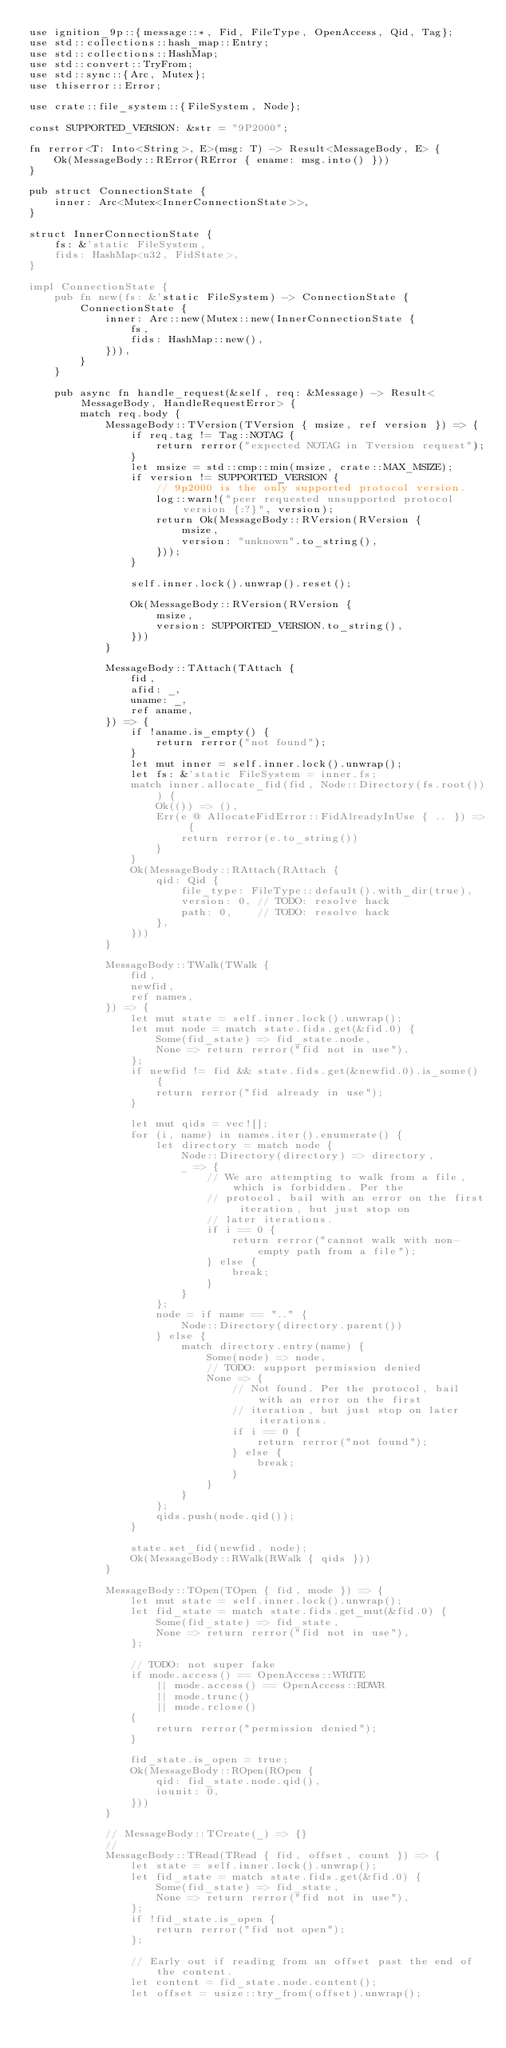Convert code to text. <code><loc_0><loc_0><loc_500><loc_500><_Rust_>use ignition_9p::{message::*, Fid, FileType, OpenAccess, Qid, Tag};
use std::collections::hash_map::Entry;
use std::collections::HashMap;
use std::convert::TryFrom;
use std::sync::{Arc, Mutex};
use thiserror::Error;

use crate::file_system::{FileSystem, Node};

const SUPPORTED_VERSION: &str = "9P2000";

fn rerror<T: Into<String>, E>(msg: T) -> Result<MessageBody, E> {
    Ok(MessageBody::RError(RError { ename: msg.into() }))
}

pub struct ConnectionState {
    inner: Arc<Mutex<InnerConnectionState>>,
}

struct InnerConnectionState {
    fs: &'static FileSystem,
    fids: HashMap<u32, FidState>,
}

impl ConnectionState {
    pub fn new(fs: &'static FileSystem) -> ConnectionState {
        ConnectionState {
            inner: Arc::new(Mutex::new(InnerConnectionState {
                fs,
                fids: HashMap::new(),
            })),
        }
    }

    pub async fn handle_request(&self, req: &Message) -> Result<MessageBody, HandleRequestError> {
        match req.body {
            MessageBody::TVersion(TVersion { msize, ref version }) => {
                if req.tag != Tag::NOTAG {
                    return rerror("expected NOTAG in Tversion request");
                }
                let msize = std::cmp::min(msize, crate::MAX_MSIZE);
                if version != SUPPORTED_VERSION {
                    // 9p2000 is the only supported protocol version.
                    log::warn!("peer requested unsupported protocol version {:?}", version);
                    return Ok(MessageBody::RVersion(RVersion {
                        msize,
                        version: "unknown".to_string(),
                    }));
                }

                self.inner.lock().unwrap().reset();

                Ok(MessageBody::RVersion(RVersion {
                    msize,
                    version: SUPPORTED_VERSION.to_string(),
                }))
            }

            MessageBody::TAttach(TAttach {
                fid,
                afid: _,
                uname: _,
                ref aname,
            }) => {
                if !aname.is_empty() {
                    return rerror("not found");
                }
                let mut inner = self.inner.lock().unwrap();
                let fs: &'static FileSystem = inner.fs;
                match inner.allocate_fid(fid, Node::Directory(fs.root())) {
                    Ok(()) => (),
                    Err(e @ AllocateFidError::FidAlreadyInUse { .. }) => {
                        return rerror(e.to_string())
                    }
                }
                Ok(MessageBody::RAttach(RAttach {
                    qid: Qid {
                        file_type: FileType::default().with_dir(true),
                        version: 0, // TODO: resolve hack
                        path: 0,    // TODO: resolve hack
                    },
                }))
            }

            MessageBody::TWalk(TWalk {
                fid,
                newfid,
                ref names,
            }) => {
                let mut state = self.inner.lock().unwrap();
                let mut node = match state.fids.get(&fid.0) {
                    Some(fid_state) => fid_state.node,
                    None => return rerror("fid not in use"),
                };
                if newfid != fid && state.fids.get(&newfid.0).is_some() {
                    return rerror("fid already in use");
                }

                let mut qids = vec![];
                for (i, name) in names.iter().enumerate() {
                    let directory = match node {
                        Node::Directory(directory) => directory,
                        _ => {
                            // We are attempting to walk from a file, which is forbidden. Per the
                            // protocol, bail with an error on the first iteration, but just stop on
                            // later iterations.
                            if i == 0 {
                                return rerror("cannot walk with non-empty path from a file");
                            } else {
                                break;
                            }
                        }
                    };
                    node = if name == ".." {
                        Node::Directory(directory.parent())
                    } else {
                        match directory.entry(name) {
                            Some(node) => node,
                            // TODO: support permission denied
                            None => {
                                // Not found. Per the protocol, bail with an error on the first
                                // iteration, but just stop on later iterations.
                                if i == 0 {
                                    return rerror("not found");
                                } else {
                                    break;
                                }
                            }
                        }
                    };
                    qids.push(node.qid());
                }

                state.set_fid(newfid, node);
                Ok(MessageBody::RWalk(RWalk { qids }))
            }

            MessageBody::TOpen(TOpen { fid, mode }) => {
                let mut state = self.inner.lock().unwrap();
                let fid_state = match state.fids.get_mut(&fid.0) {
                    Some(fid_state) => fid_state,
                    None => return rerror("fid not in use"),
                };

                // TODO: not super fake
                if mode.access() == OpenAccess::WRITE
                    || mode.access() == OpenAccess::RDWR
                    || mode.trunc()
                    || mode.rclose()
                {
                    return rerror("permission denied");
                }

                fid_state.is_open = true;
                Ok(MessageBody::ROpen(ROpen {
                    qid: fid_state.node.qid(),
                    iounit: 0,
                }))
            }

            // MessageBody::TCreate(_) => {}
            //
            MessageBody::TRead(TRead { fid, offset, count }) => {
                let state = self.inner.lock().unwrap();
                let fid_state = match state.fids.get(&fid.0) {
                    Some(fid_state) => fid_state,
                    None => return rerror("fid not in use"),
                };
                if !fid_state.is_open {
                    return rerror("fid not open");
                };

                // Early out if reading from an offset past the end of the content.
                let content = fid_state.node.content();
                let offset = usize::try_from(offset).unwrap();</code> 